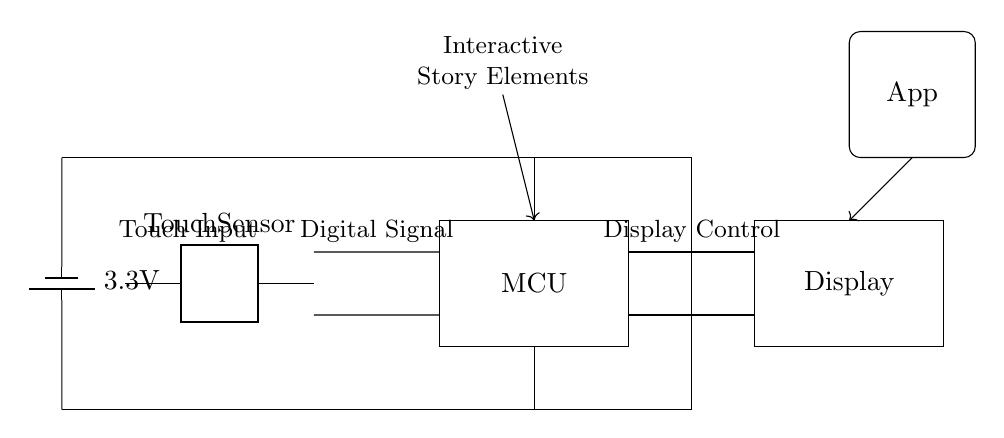What type of sensor is used in this circuit? The circuit includes a touch sensor component, which is clearly labeled as "Touch Sensor" in the diagram.
Answer: Touch Sensor What is the voltage provided by the power supply? The circuit diagram shows a battery labeled with a voltage of 3.3 volts, which indicates that this is the power supply voltage.
Answer: 3.3 volts What does the MCU represent in the circuit? The MCU stands for Microcontroller Unit, which is depicted as a rectangle labeled "MCU" in the circuit diagram. It processes signals from the touch sensor.
Answer: Microcontroller Unit How many connections are there between the touch sensor and the microcontroller? There are two connections shown: one for the touch input and one for the digital signal. These are indicated by the short lines connecting both components.
Answer: Two connections What is the purpose of the display in this circuit? The display is connected to the microcontroller and serves the purpose of showing visual feedback or content, as indicated by its label "Display" and the connection lines.
Answer: Visual feedback What is the function of the battery in this circuit? The battery functions as the power supply, providing the necessary voltage to power the entire circuit, indicated by its placement at the top and connection to other components.
Answer: Power supply How does the app interact with the circuit? The arrow pointing from the App icon to the microcontroller indicates that the app sends signals or commands to the microcontroller, which allows for interaction between the user interface and the circuit.
Answer: User interface interaction 